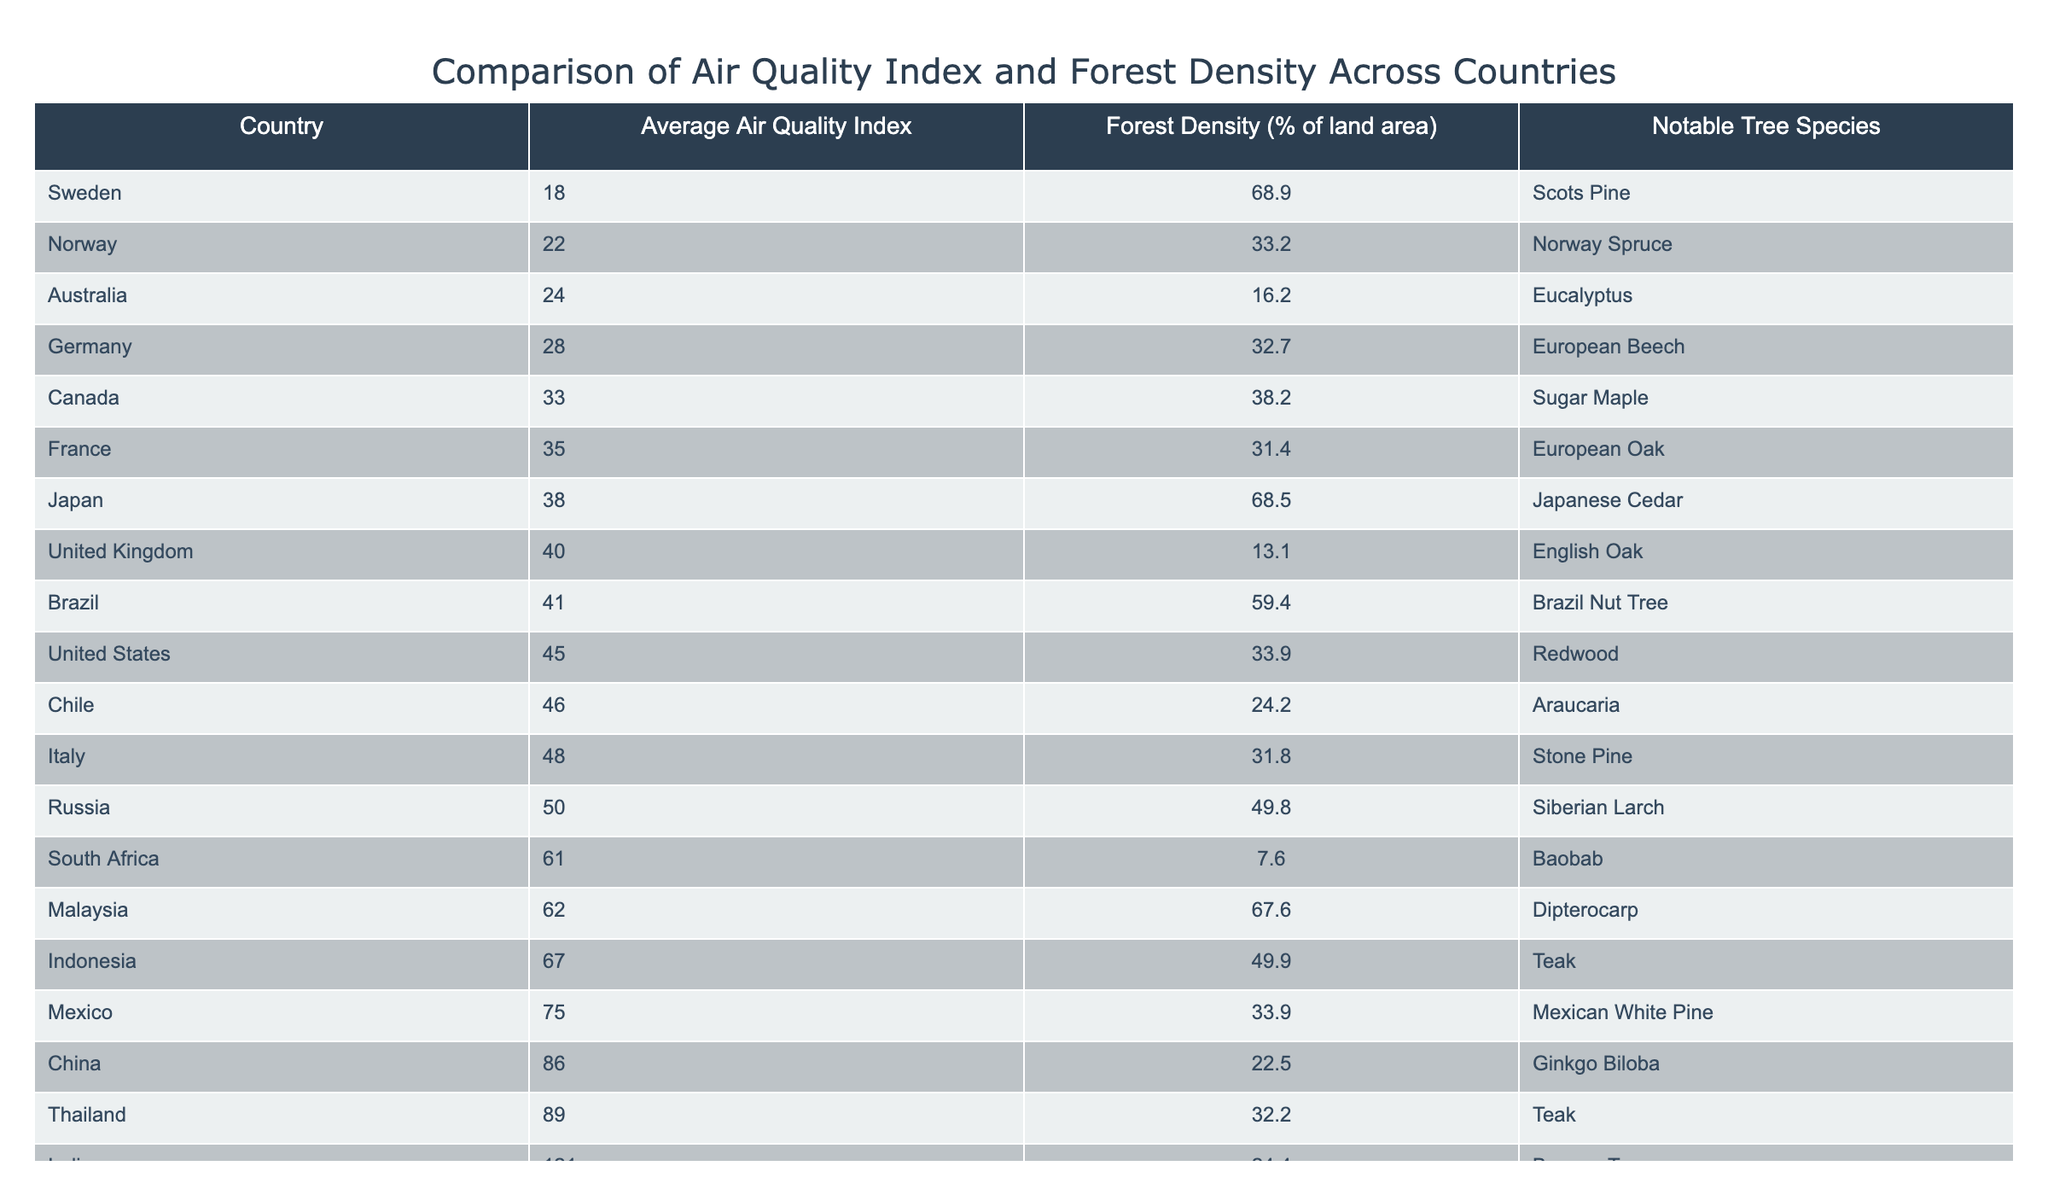What is the Average Air Quality Index of Brazil? The Average Air Quality Index for Brazil is provided directly in the table. By locating Brazil in the 'Country' column and referring to its corresponding 'Average Air Quality Index' value, we find it is 41.
Answer: 41 Which country has the highest forest density? To find the country with the highest forest density, we examine the 'Forest Density (% of land area)' column. The highest value is 67.6%, associated with Malaysia.
Answer: Malaysia Is the statement "China has a lower forest density than the United States" true? We can find China and the United States in the table. China's forest density is 22.5%, while the United States has a forest density of 33.9%. Since 22.5% is less than 33.9%, the statement is indeed true.
Answer: Yes What is the average Air Quality Index of the top three countries with the lowest Air Quality Index? We first identify the three countries with the lowest Average Air Quality Index values: Sweden (18), Norway (22), and Australia (24). Then, we sum these values: 18 + 22 + 24 = 64. Dividing by 3 gives us an average of 64 / 3 = 21.33.
Answer: 21.33 Which country has a forest density closer to the average Air Quality Index of India? First, we find the Average Air Quality Index of India, given as 121. Next, we would look for the country with forest density values closest to this pollution index. The forest density values span from 7.6% (South Africa) to 68.9% (Sweden), so in this case, we conclude that there is no country with forest density close to India's pollution level.
Answer: None How many countries have an Average Air Quality Index higher than 50? By examining the 'Average Air Quality Index' column, we see the values higher than 50 correspond to China (86), India (121), Indonesia (67), and Thailand (89). Thus, there are four countries with an index over 50.
Answer: 4 What is the difference in forest density between the country with the highest and lowest forest density? After identifying the country with the highest forest density (Malaysia at 67.6%) and the country with the lowest (South Africa at 7.6%), we calculate the difference: 67.6% - 7.6% = 60%.
Answer: 60% Which notable tree species is associated with Germany? To find the notable tree species for Germany, we locate Germany in the 'Country' column and then refer to the corresponding 'Notable Tree Species' column, which shows that the species is European Beech.
Answer: European Beech 